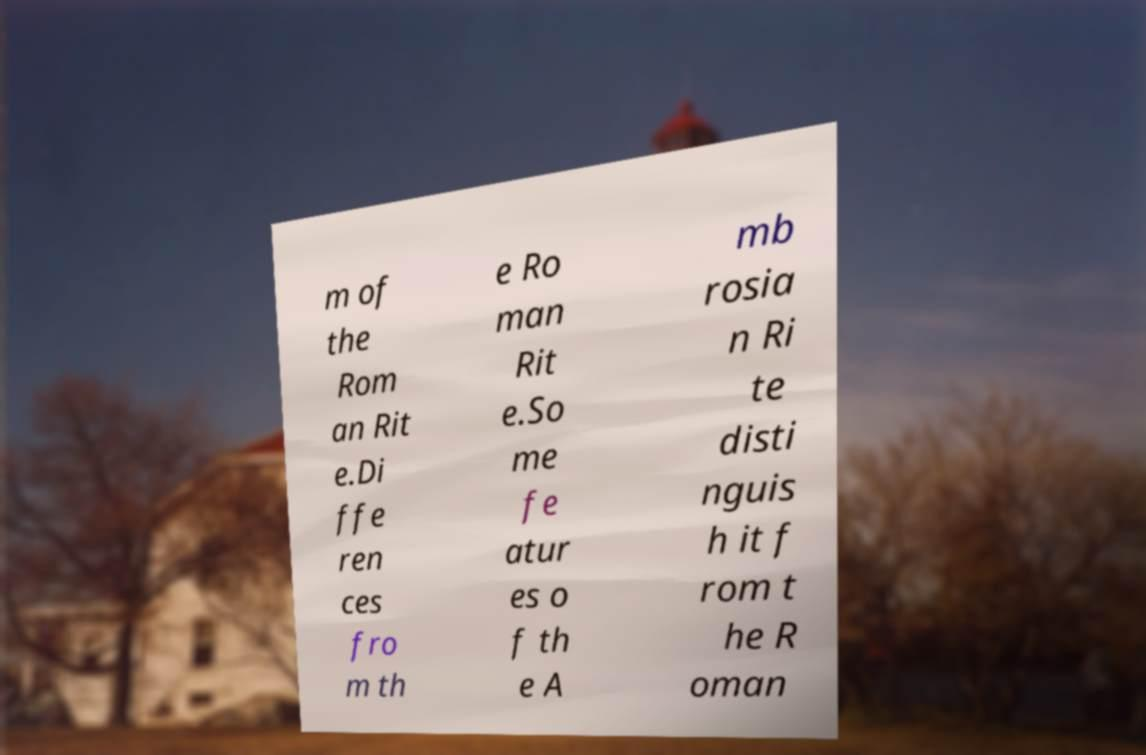I need the written content from this picture converted into text. Can you do that? m of the Rom an Rit e.Di ffe ren ces fro m th e Ro man Rit e.So me fe atur es o f th e A mb rosia n Ri te disti nguis h it f rom t he R oman 